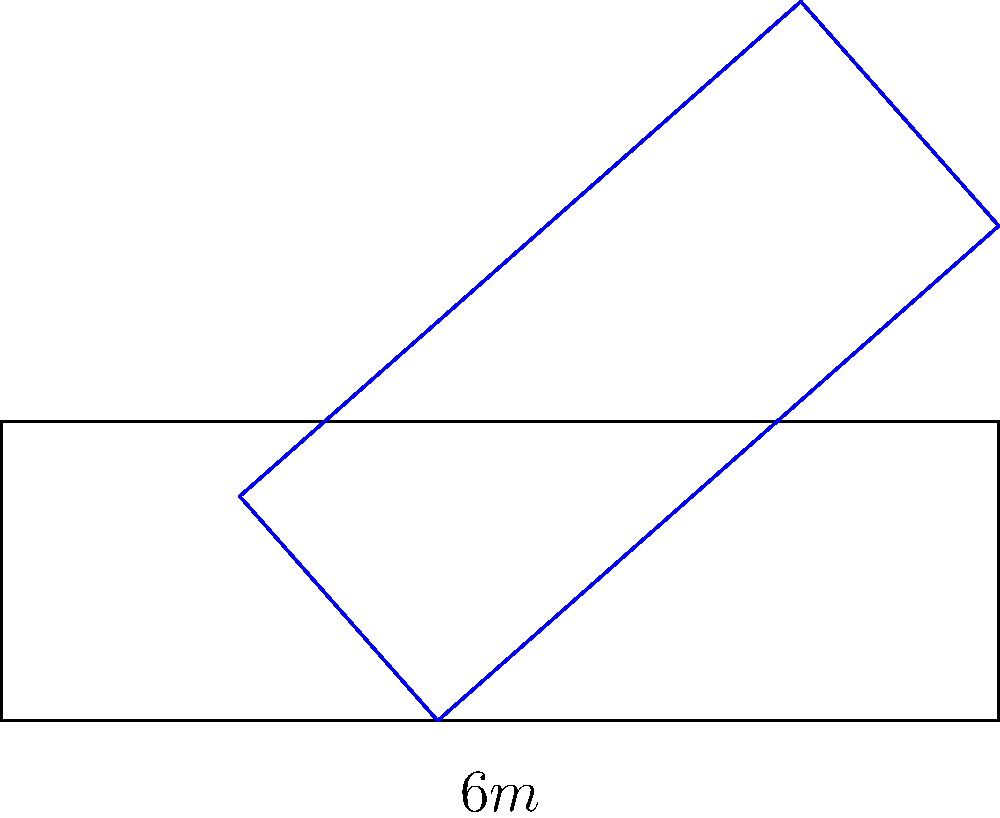As a driving expert, determine the optimal angle $\theta$ for parallel parking a car with a length of 4.5 meters into a parking space that is 6 meters long. Assume the car can be perfectly maneuvered and ignore the width of the car and space. Round your answer to the nearest degree. To find the optimal angle for parallel parking, we need to use trigonometry. Here's a step-by-step explanation:

1) In the optimal position, the car forms a right triangle with the parking space.

2) The hypotenuse of this triangle is the length of the car (4.5 m).

3) The adjacent side of the triangle is the length of the parking space (6 m).

4) We can use the cosine function to find the angle:

   $$\cos(\theta) = \frac{\text{adjacent}}{\text{hypotenuse}} = \frac{6}{4.5}$$

5) To solve for $\theta$, we take the inverse cosine (arccos) of both sides:

   $$\theta = \arccos(\frac{6}{4.5})$$

6) Calculate:
   $$\theta = \arccos(1.3333...) \approx 41.4096...°$$

7) Rounding to the nearest degree:
   $$\theta \approx 41°$$

This angle allows the car to fit perfectly into the space when backed in at this angle.
Answer: 41° 